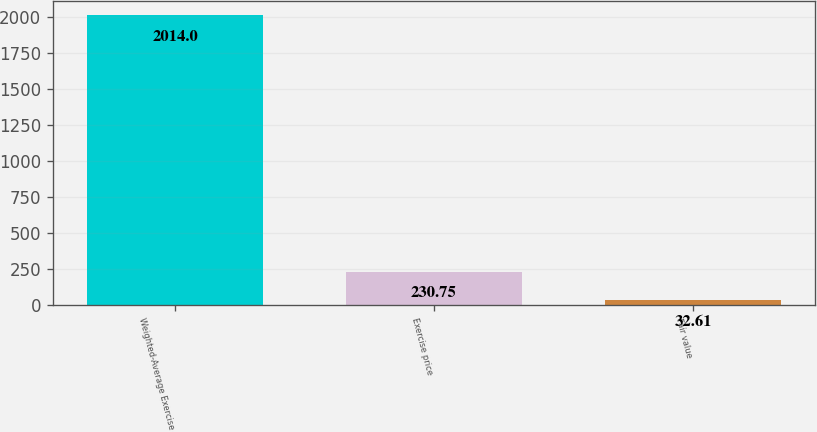Convert chart to OTSL. <chart><loc_0><loc_0><loc_500><loc_500><bar_chart><fcel>Weighted-Average Exercise<fcel>Exercise price<fcel>Fair value<nl><fcel>2014<fcel>230.75<fcel>32.61<nl></chart> 